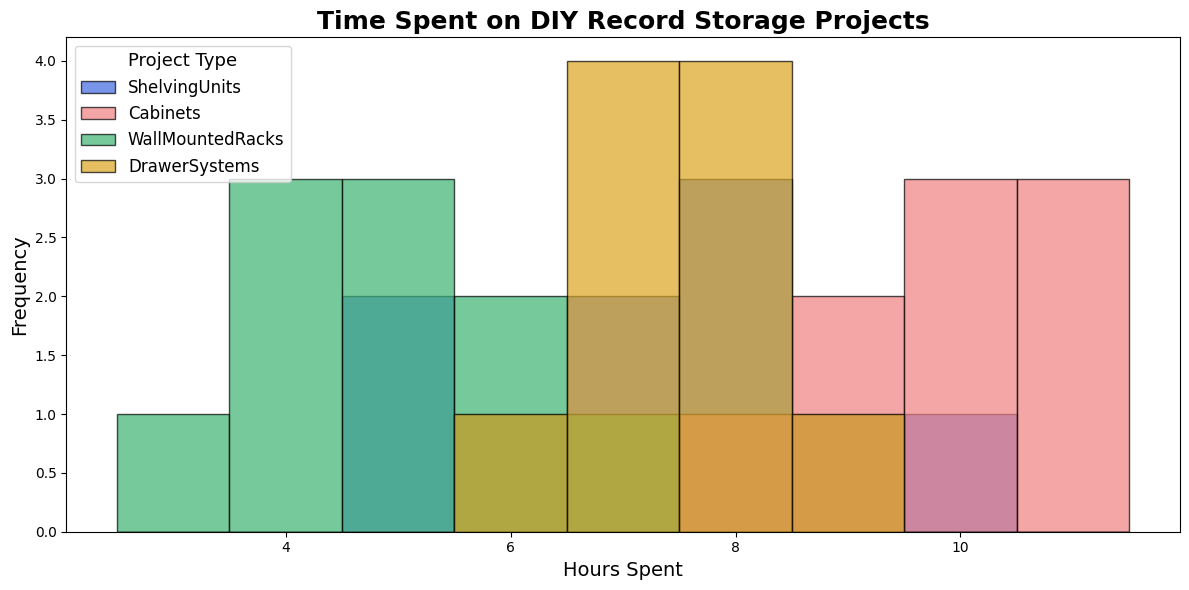How many different project types are displayed in the histogram? The legend in the histogram displays different colors corresponding to project types. By counting these colors, we identify the number of project types.
Answer: 4 Which project type shows the highest frequency of a single time interval? The height of bars in the histogram represents the frequency of occurrence. Observe which project type has the tallest bar along any given bin.
Answer: Cabinets What is the total frequency for hours between 4 and 6 for Shelving Units? Sum the heights of the bars for Shelving Units that fall between the hours 4 and 6.
Answer: 2+2 = 4 Which project type has the longest span of time spent? Compare the range of hours each project type covers by examining the bins they occupy from lowest to highest.
Answer: Cabinets What is the average frequency of the Wall Mounted Racks across all bins? Add the frequencies of all bins for Wall Mounted Racks and divide by the number of bins it occupies.
Answer: (2+2+3+1+1+1)/6 = 1.67 Which project type appears to have a more evenly distributed time spent based on the histogram? Examine the spread of frequencies across the bins; more uniform heights of bars indicate an even distribution.
Answer: Drawer Systems Is the frequency of hours spent on Drawer Systems projects mostly above or below 7 hours? Count the frequencies in bins above 7 hours and compare them to those below or exactly at 7 hours.
Answer: Below How does the peak frequency for Shelving Units compare to the peak frequency for Wall Mounted Racks? Identify the tallest bar for both Shelving Units and Wall Mounted Racks, then compare their heights.
Answer: Shelving Units > Wall Mounted Racks 